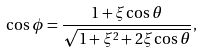<formula> <loc_0><loc_0><loc_500><loc_500>\cos \phi = \frac { 1 + \xi \cos \theta } { \sqrt { 1 + \xi ^ { 2 } + 2 \xi \cos \theta } } ,</formula> 